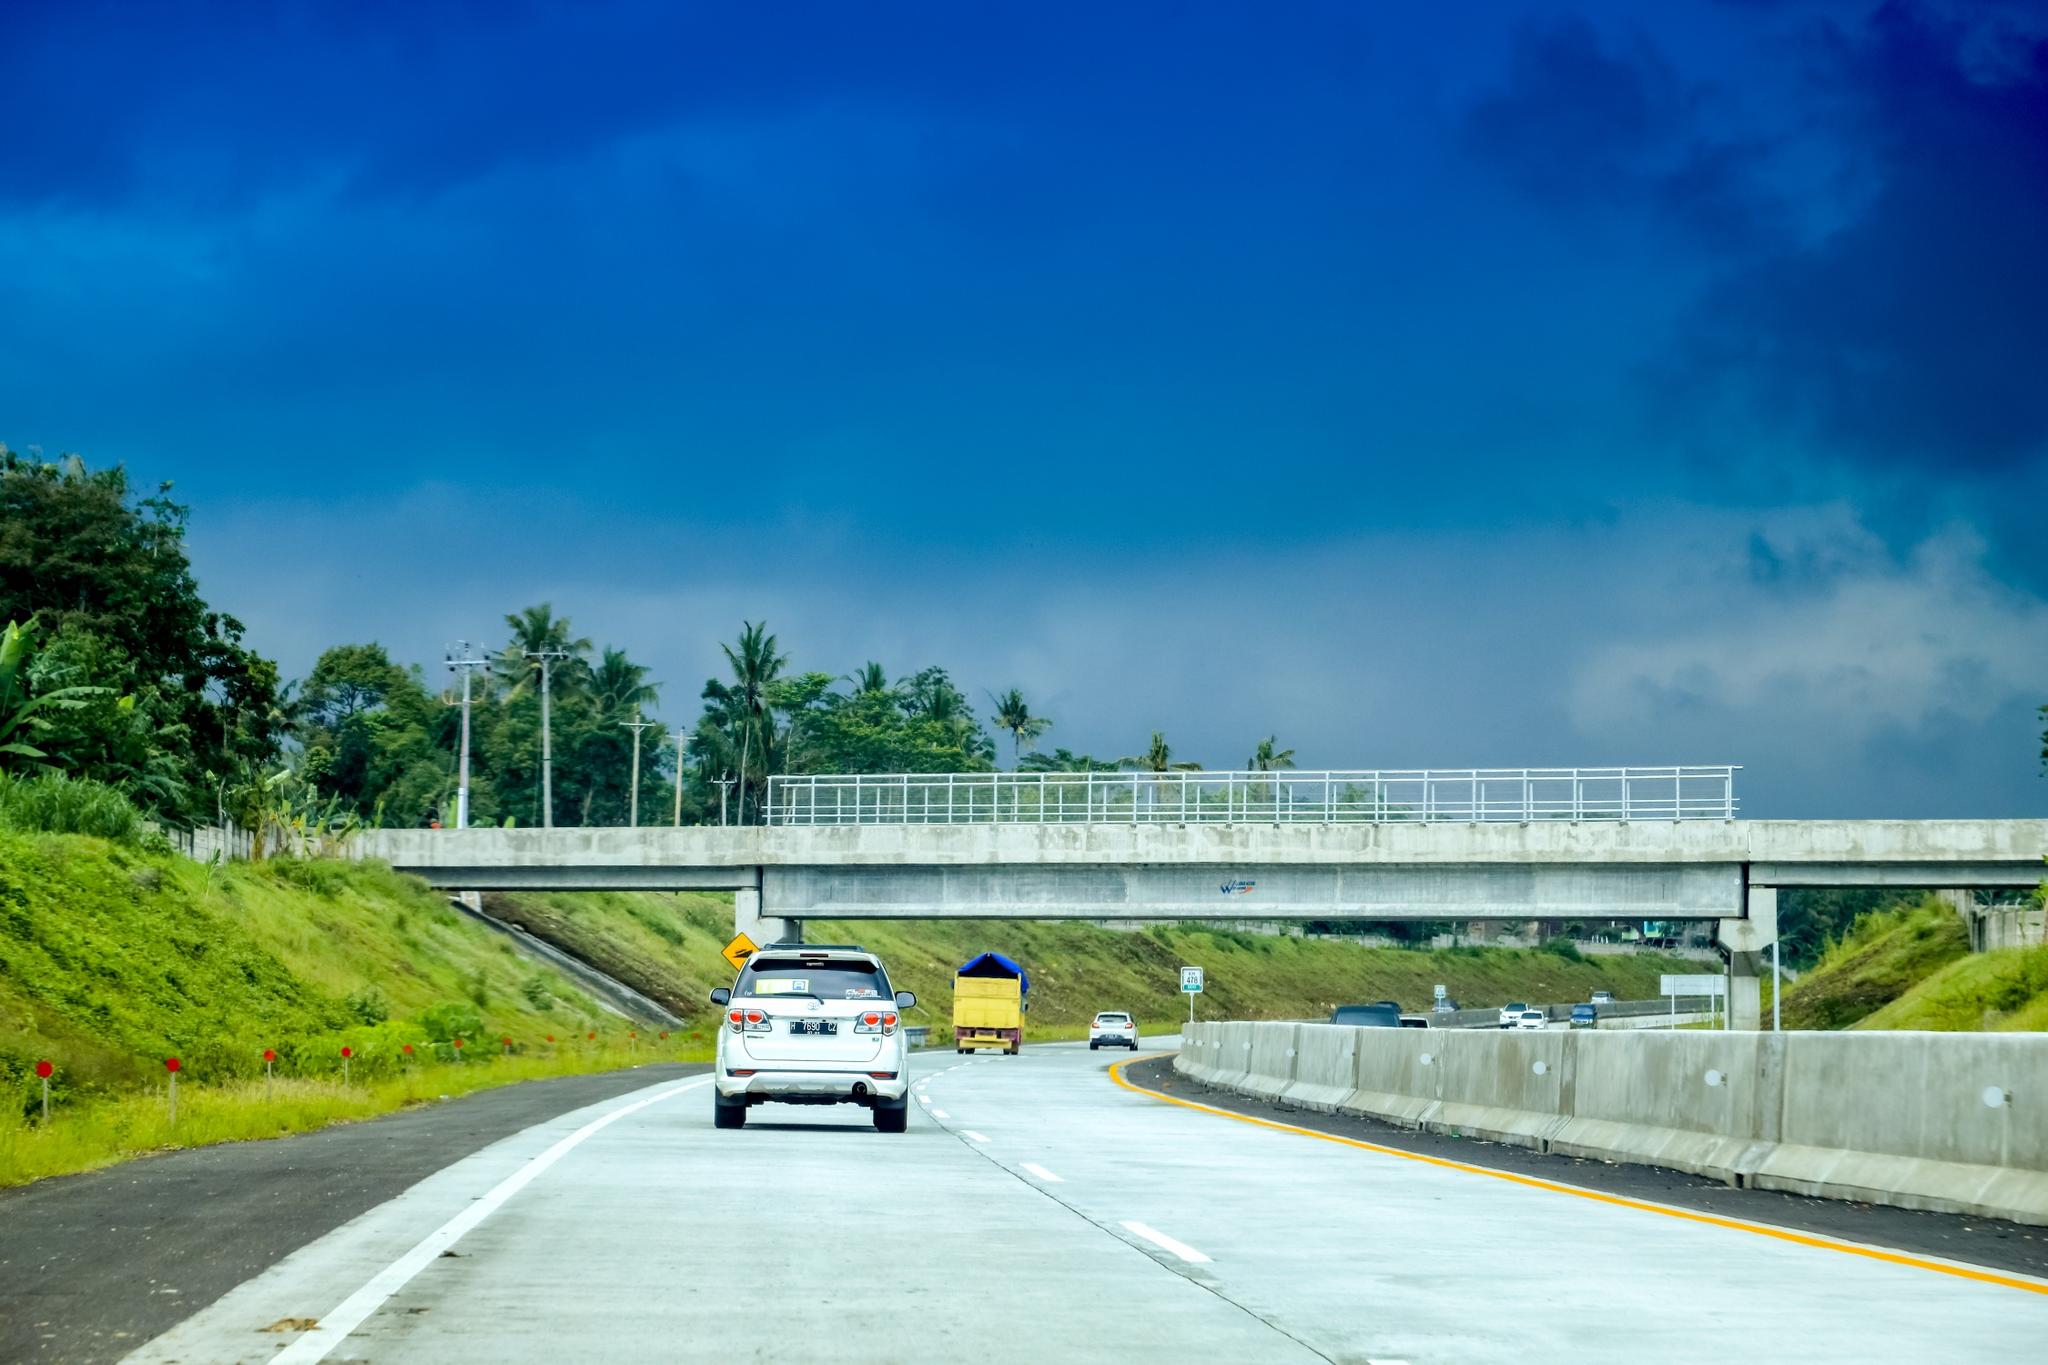Imagine an adventurous story that could unfold on this highway. As the white car cruises down the highway, its occupants are unaware that they've just crossed into an area enchanted by old folklore. Suddenly, their radio cackles to life, playing an unfamiliar, ancient tune. They soon notice peculiar markings on the concrete bridge, shimmering as if whispering secrets. Curiosity piqued, they follow the invisible trail these signs suggest, leading them off the beaten path to a hidden valley. There, they discover a mystical festival celebrating the spirits of the forest. The car's journey becomes an adventure through time, as they are embraced by the magical essence of this forgotten land and its timeless stories. 